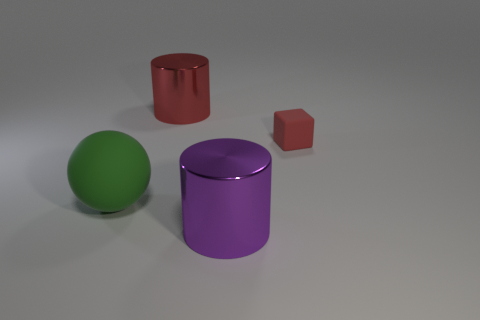There is a small red matte block; are there any red matte objects in front of it? Upon inspecting the image, it appears that no red matte objects are situated in front of the small red block. The block is positioned in a way that all other objects are either beside it or behind it from this perspective. 